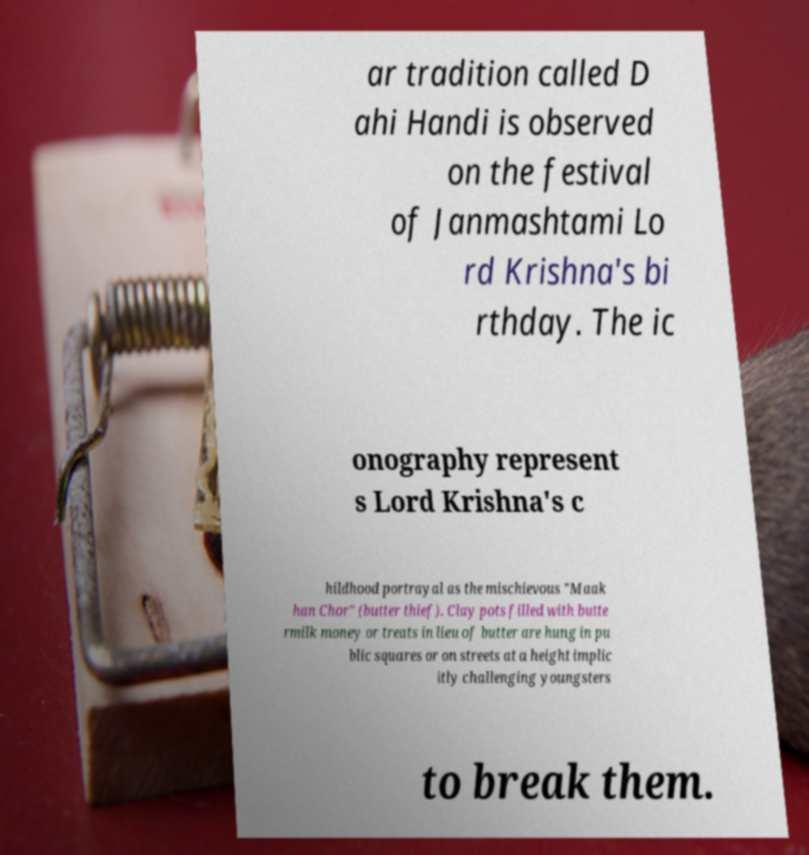Please read and relay the text visible in this image. What does it say? ar tradition called D ahi Handi is observed on the festival of Janmashtami Lo rd Krishna's bi rthday. The ic onography represent s Lord Krishna's c hildhood portrayal as the mischievous "Maak han Chor" (butter thief). Clay pots filled with butte rmilk money or treats in lieu of butter are hung in pu blic squares or on streets at a height implic itly challenging youngsters to break them. 